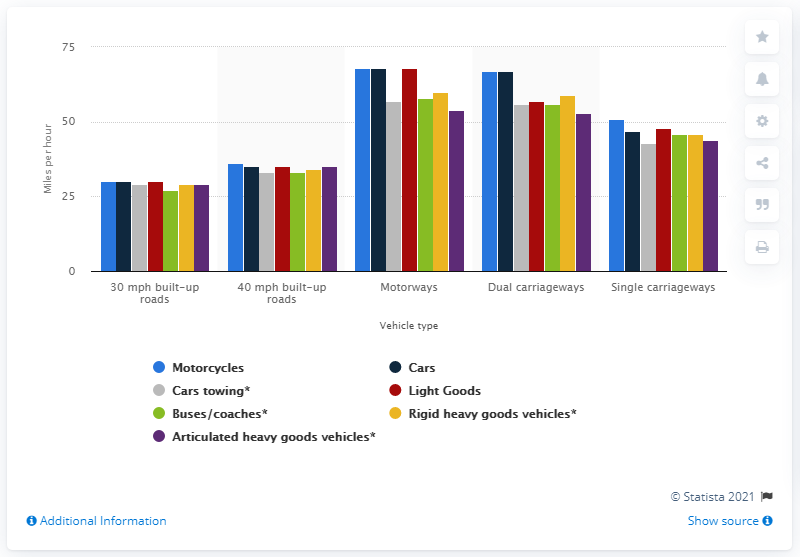Indicate a few pertinent items in this graphic. The fastest vehicles on dual and single carriageways and 40 mph built-up roads were motorcycles. 